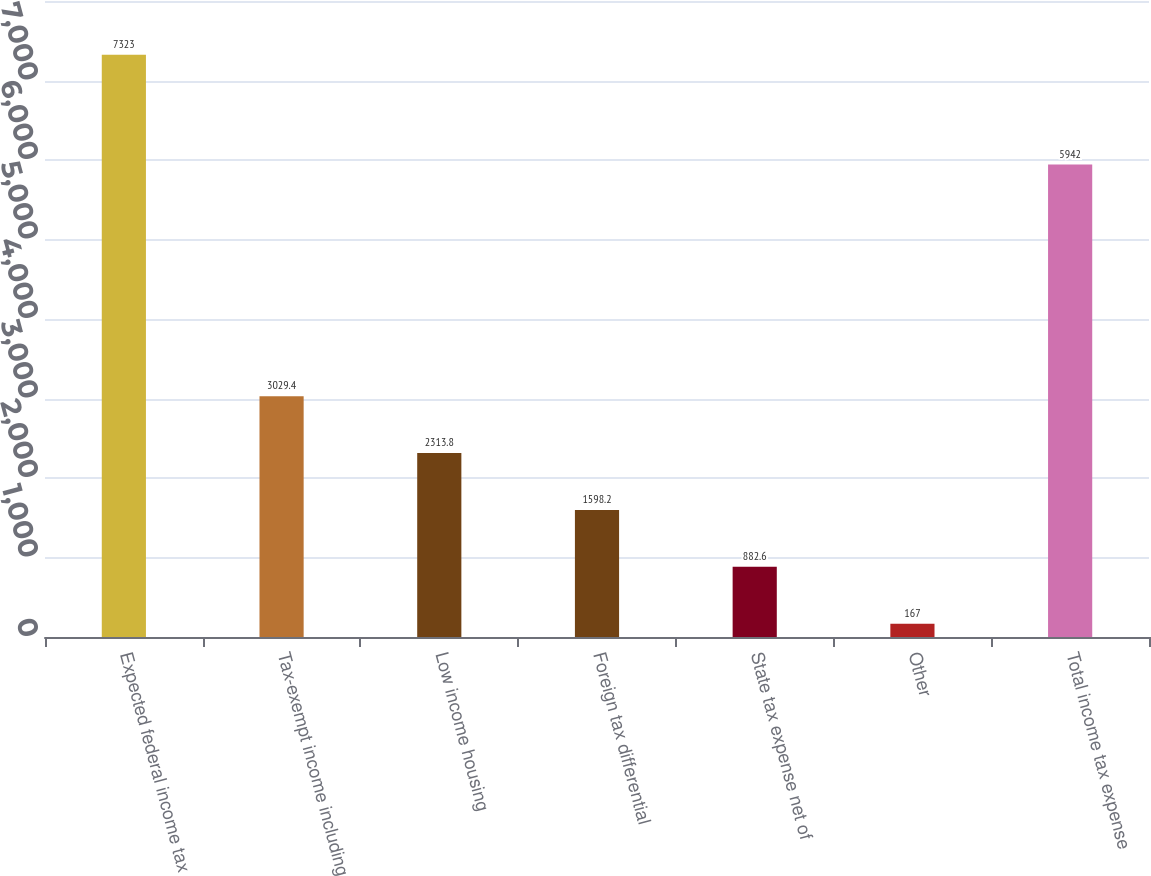<chart> <loc_0><loc_0><loc_500><loc_500><bar_chart><fcel>Expected federal income tax<fcel>Tax-exempt income including<fcel>Low income housing<fcel>Foreign tax differential<fcel>State tax expense net of<fcel>Other<fcel>Total income tax expense<nl><fcel>7323<fcel>3029.4<fcel>2313.8<fcel>1598.2<fcel>882.6<fcel>167<fcel>5942<nl></chart> 